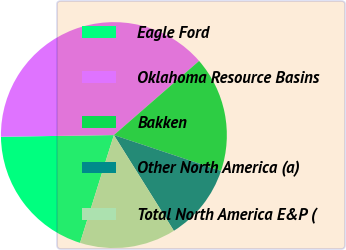Convert chart to OTSL. <chart><loc_0><loc_0><loc_500><loc_500><pie_chart><fcel>Eagle Ford<fcel>Oklahoma Resource Basins<fcel>Bakken<fcel>Other North America (a)<fcel>Total North America E&P (<nl><fcel>19.92%<fcel>38.84%<fcel>16.53%<fcel>10.96%<fcel>13.75%<nl></chart> 